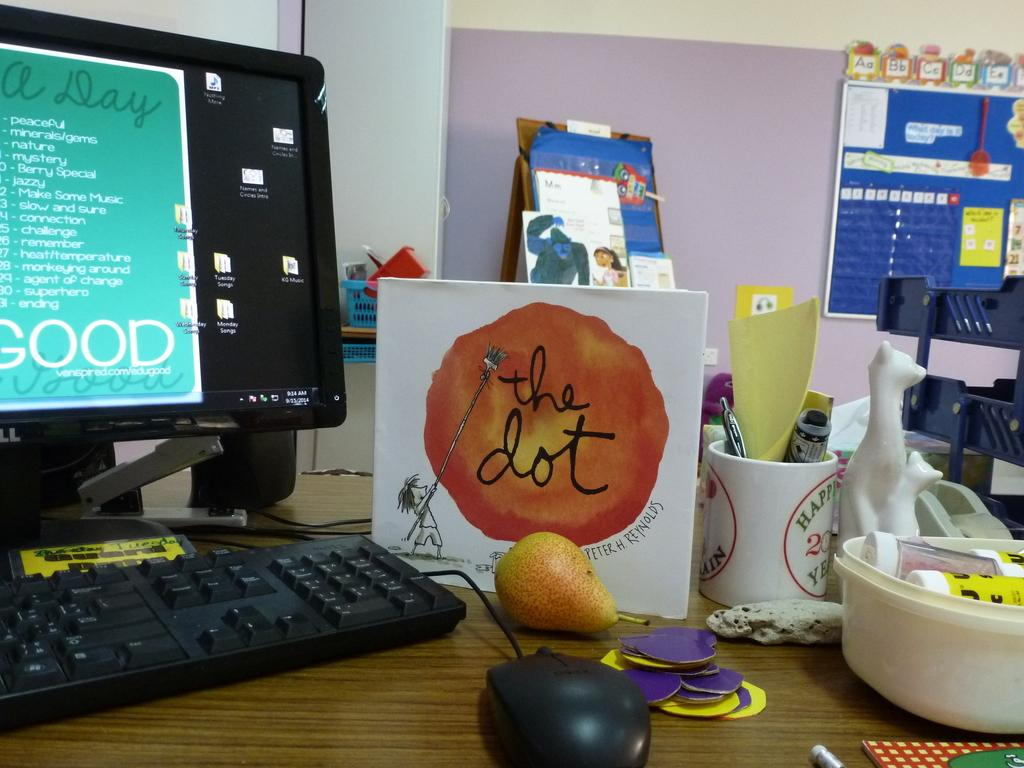What type of room is the image taken in? The image is taken in a room. What furniture is present in the room? There is a wooden table in the image. What electronic devices are on the table? There is a keyboard, a monitor, and a board on the table. What items are on the table that are not electronic devices? There is a cup, fruits, a bowl, and a toy on the table. What is the background of the image? There is a wall behind the monitor. What type of partner does the mouse have in the image? There is no partner for the mouse in the image, as it is a toy mouse and not a real one. What attempt does the mouse make in the image? There is no attempt made by the mouse in the image, as it is a toy mouse and not a real one. 